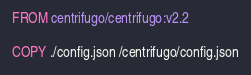<code> <loc_0><loc_0><loc_500><loc_500><_Dockerfile_>FROM centrifugo/centrifugo:v2.2

COPY ./config.json /centrifugo/config.json
</code> 